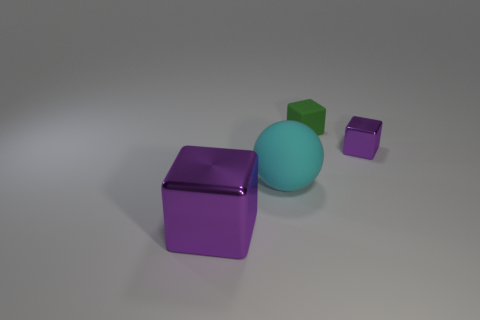Is there a large shiny thing that has the same color as the small rubber object?
Make the answer very short. No. Does the tiny rubber object have the same shape as the metallic object behind the large cyan matte sphere?
Your answer should be compact. Yes. Is there another object made of the same material as the tiny green thing?
Your answer should be very brief. Yes. There is a metal cube that is in front of the purple metallic cube behind the big purple cube; is there a large purple object that is in front of it?
Your answer should be very brief. No. What number of other things are the same shape as the green thing?
Keep it short and to the point. 2. There is a metallic block that is in front of the purple metal object behind the purple metal thing that is left of the tiny purple metal block; what is its color?
Provide a short and direct response. Purple. How many blue matte cylinders are there?
Ensure brevity in your answer.  0. What number of big things are green cubes or purple shiny cylinders?
Offer a very short reply. 0. There is a object that is the same size as the rubber sphere; what is its shape?
Provide a succinct answer. Cube. Is there any other thing that is the same size as the green rubber object?
Your answer should be very brief. Yes. 